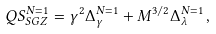Convert formula to latex. <formula><loc_0><loc_0><loc_500><loc_500>Q S _ { S G Z } ^ { N = 1 } = \gamma ^ { 2 } \Delta _ { \gamma } ^ { N = 1 } + M ^ { 3 / 2 } \Delta _ { \lambda } ^ { N = 1 } \, ,</formula> 